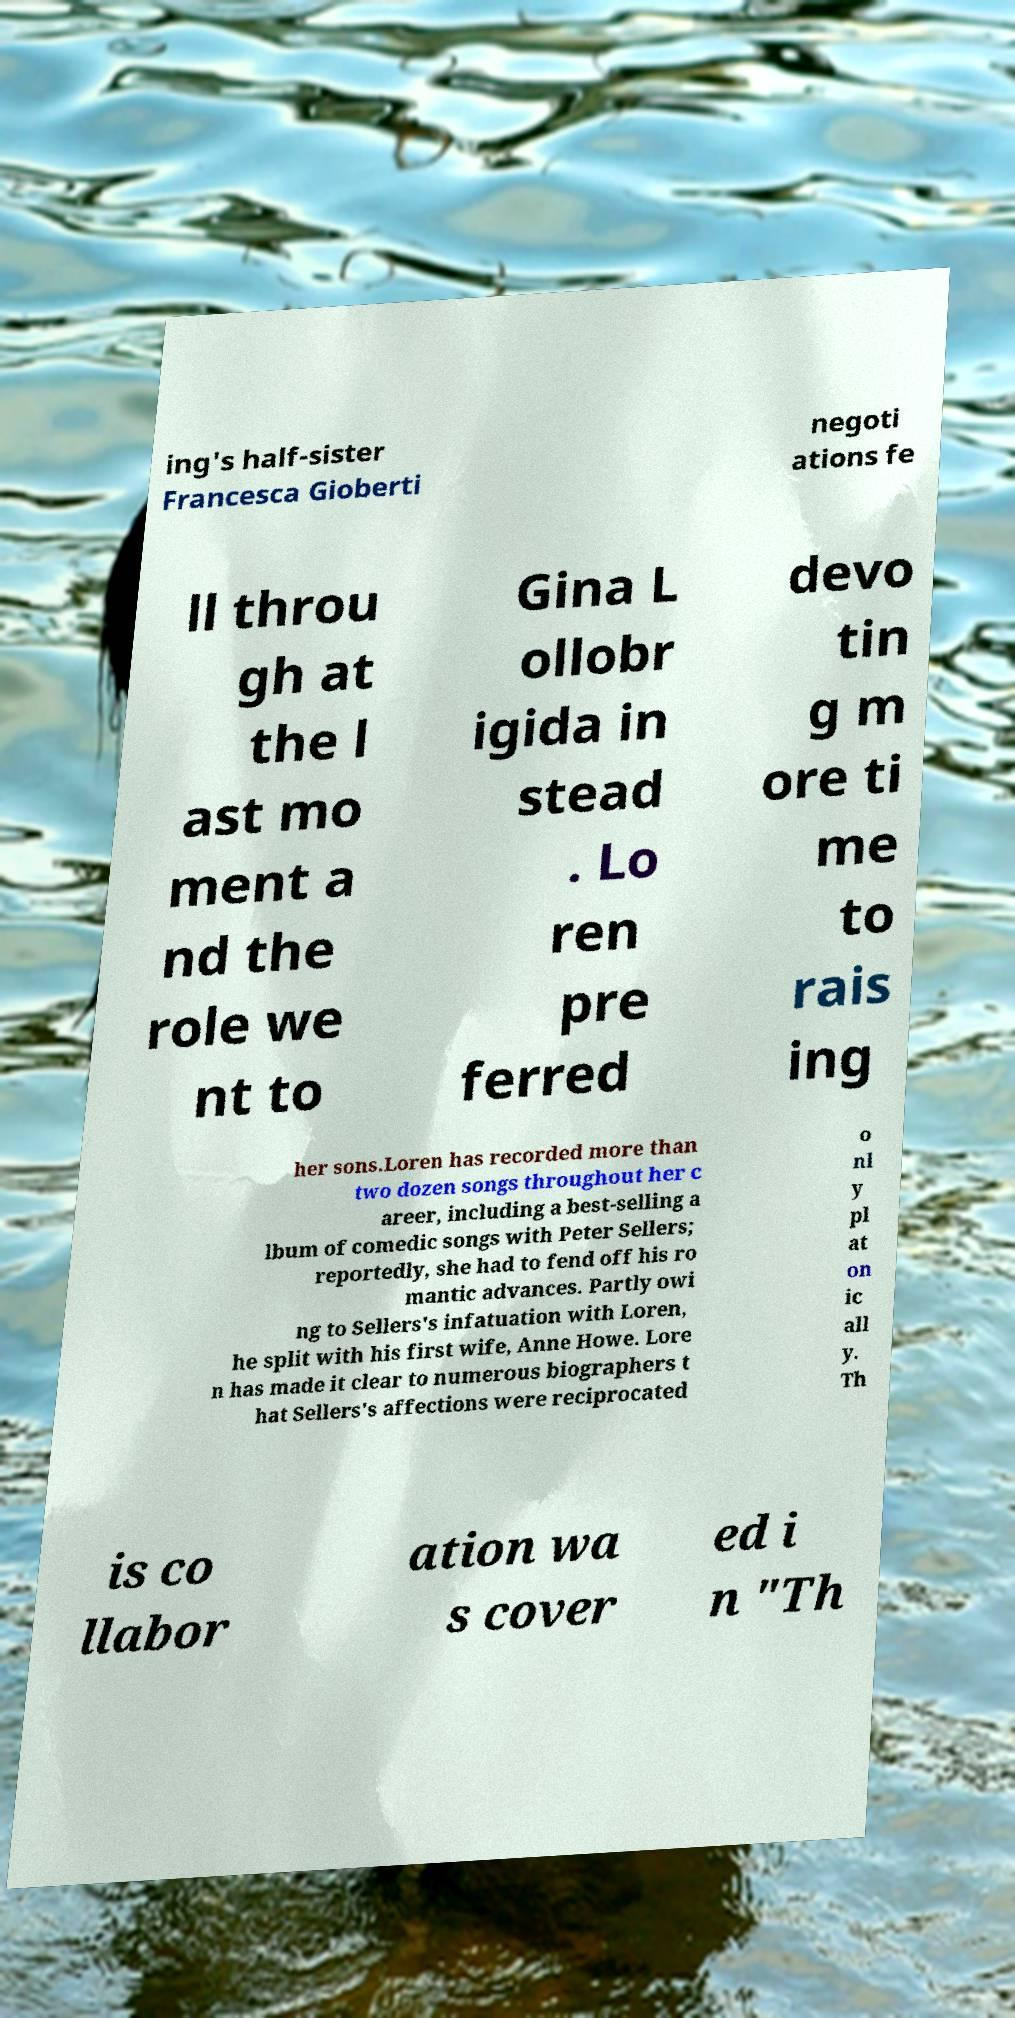Please read and relay the text visible in this image. What does it say? ing's half-sister Francesca Gioberti negoti ations fe ll throu gh at the l ast mo ment a nd the role we nt to Gina L ollobr igida in stead . Lo ren pre ferred devo tin g m ore ti me to rais ing her sons.Loren has recorded more than two dozen songs throughout her c areer, including a best-selling a lbum of comedic songs with Peter Sellers; reportedly, she had to fend off his ro mantic advances. Partly owi ng to Sellers's infatuation with Loren, he split with his first wife, Anne Howe. Lore n has made it clear to numerous biographers t hat Sellers's affections were reciprocated o nl y pl at on ic all y. Th is co llabor ation wa s cover ed i n "Th 